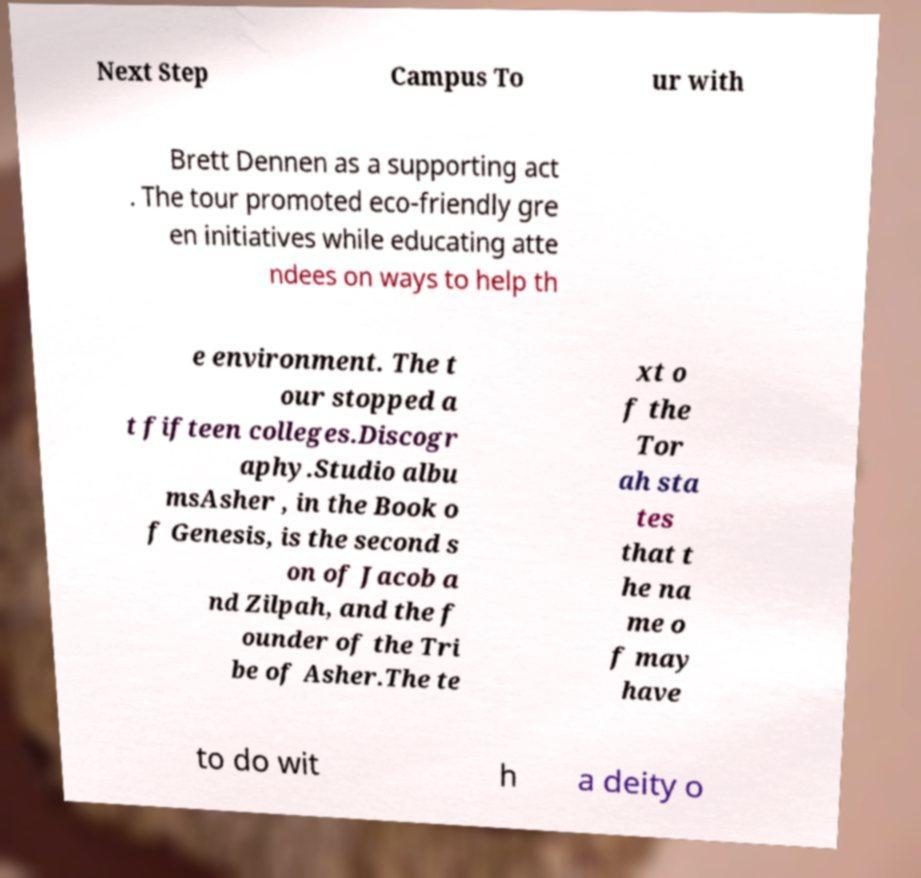I need the written content from this picture converted into text. Can you do that? Next Step Campus To ur with Brett Dennen as a supporting act . The tour promoted eco-friendly gre en initiatives while educating atte ndees on ways to help th e environment. The t our stopped a t fifteen colleges.Discogr aphy.Studio albu msAsher , in the Book o f Genesis, is the second s on of Jacob a nd Zilpah, and the f ounder of the Tri be of Asher.The te xt o f the Tor ah sta tes that t he na me o f may have to do wit h a deity o 